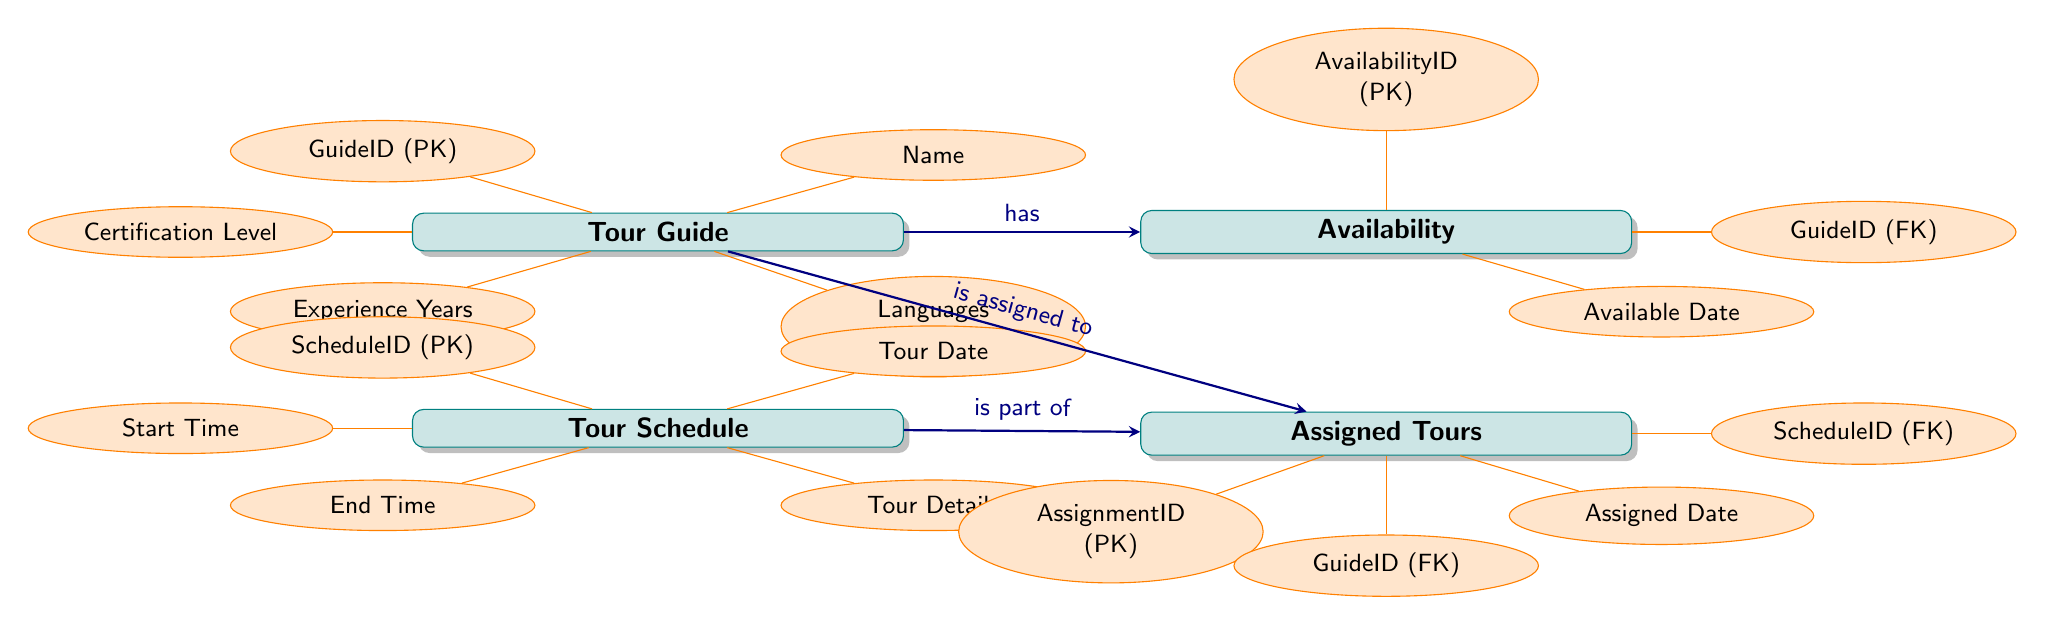What is the primary key for the Tour Guide entity? The primary key for the Tour Guide entity is labeled as "GuideID (PK)" in the diagram. This indicates that it uniquely identifies each tour guide in the system.
Answer: GuideID How many attributes does the Tour Schedule entity have? The Tour Schedule entity is connected to five attributes: ScheduleID, Tour Date, Start Time, End Time, and Tour Details. Therefore, it has a total of five attributes.
Answer: 5 What is the relationship between Tour Guide and Assigned Tours? The diagram shows an arrow pointing from Tour Guide to Assigned Tours with the label "is assigned to," indicating that tour guides are assigned to various tours.
Answer: is assigned to Which entity has a foreign key named GuideID? The Availability entity includes a foreign key named "GuideID (FK)", which indicates that it references the Tour Guide entity, connecting availability data to specific tour guides.
Answer: Availability What kind of relationship does Tour Schedule have with Assigned Tours? The relationship depicted in the diagram shows that the Tour Schedule is indicated as "is part of" the Assigned Tours entity, indicating a connection where assigned tours are based on a specific schedule.
Answer: is part of If a Tour Guide is assigned to a tour, which other entity must be referenced? The Assigned Tours entity references both the GuideID from the Tour Guide entity and the ScheduleID from the Tour Schedule entity, meaning both must be considered when a tour guide is assigned.
Answer: Tour Schedule How many foreign keys are present in the Assigned Tours entity? The Assigned Tours entity has two foreign keys: GuideID and ScheduleID. These keys are used to link the assigned tours to the corresponding tour guides and schedules.
Answer: 2 What does the Availability entity record about Tour Guides? The Availability entity records information about when a tour guide is available, including the Available Date, Start Time, and End Time associated with that guide.
Answer: availability of tour guides 